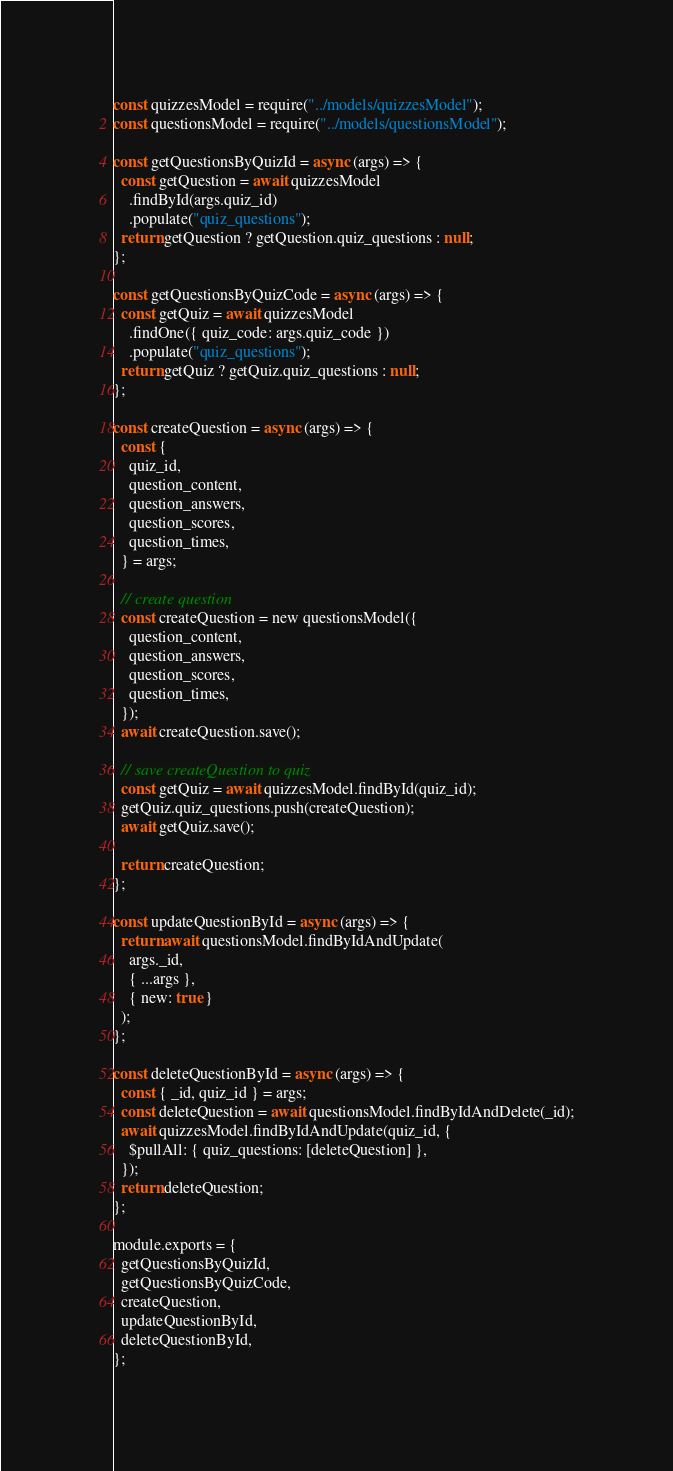<code> <loc_0><loc_0><loc_500><loc_500><_JavaScript_>const quizzesModel = require("../models/quizzesModel");
const questionsModel = require("../models/questionsModel");

const getQuestionsByQuizId = async (args) => {
  const getQuestion = await quizzesModel
    .findById(args.quiz_id)
    .populate("quiz_questions");
  return getQuestion ? getQuestion.quiz_questions : null;
};

const getQuestionsByQuizCode = async (args) => {
  const getQuiz = await quizzesModel
    .findOne({ quiz_code: args.quiz_code })
    .populate("quiz_questions");
  return getQuiz ? getQuiz.quiz_questions : null;
};

const createQuestion = async (args) => {
  const {
    quiz_id,
    question_content,
    question_answers,
    question_scores,
    question_times,
  } = args;

  // create question
  const createQuestion = new questionsModel({
    question_content,
    question_answers,
    question_scores,
    question_times,
  });
  await createQuestion.save();

  // save createQuestion to quiz
  const getQuiz = await quizzesModel.findById(quiz_id);
  getQuiz.quiz_questions.push(createQuestion);
  await getQuiz.save();

  return createQuestion;
};

const updateQuestionById = async (args) => {
  return await questionsModel.findByIdAndUpdate(
    args._id,
    { ...args },
    { new: true }
  );
};

const deleteQuestionById = async (args) => {
  const { _id, quiz_id } = args;
  const deleteQuestion = await questionsModel.findByIdAndDelete(_id);
  await quizzesModel.findByIdAndUpdate(quiz_id, {
    $pullAll: { quiz_questions: [deleteQuestion] },
  });
  return deleteQuestion;
};

module.exports = {
  getQuestionsByQuizId,
  getQuestionsByQuizCode,
  createQuestion,
  updateQuestionById,
  deleteQuestionById,
};
</code> 